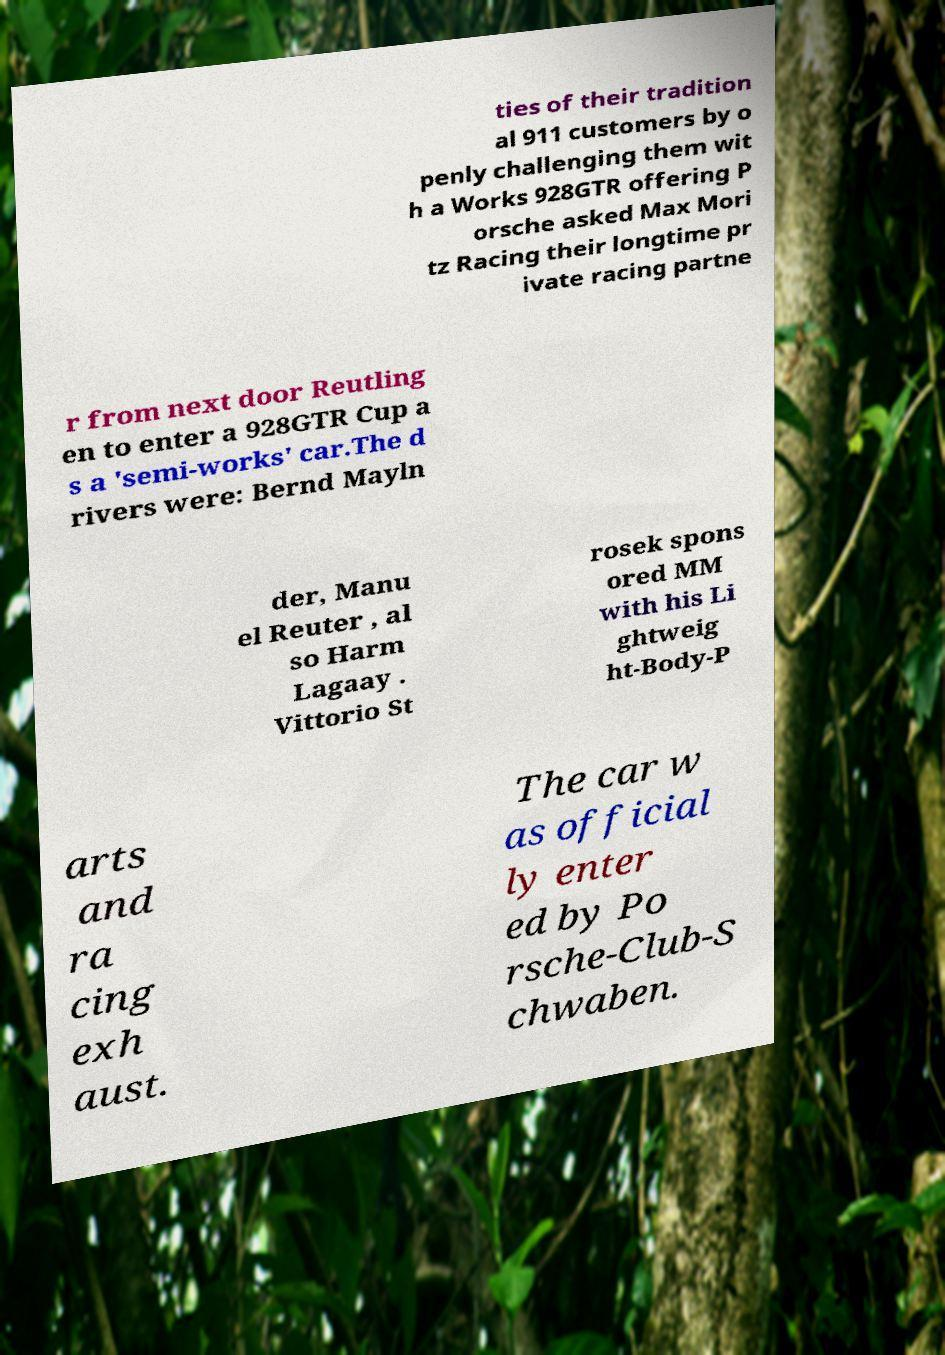For documentation purposes, I need the text within this image transcribed. Could you provide that? ties of their tradition al 911 customers by o penly challenging them wit h a Works 928GTR offering P orsche asked Max Mori tz Racing their longtime pr ivate racing partne r from next door Reutling en to enter a 928GTR Cup a s a 'semi-works' car.The d rivers were: Bernd Mayln der, Manu el Reuter , al so Harm Lagaay . Vittorio St rosek spons ored MM with his Li ghtweig ht-Body-P arts and ra cing exh aust. The car w as official ly enter ed by Po rsche-Club-S chwaben. 